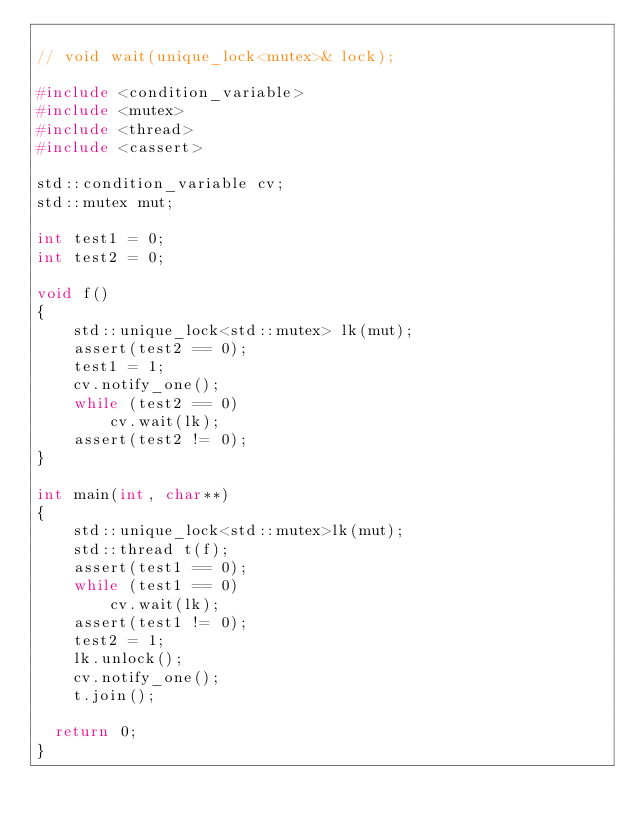Convert code to text. <code><loc_0><loc_0><loc_500><loc_500><_C++_>
// void wait(unique_lock<mutex>& lock);

#include <condition_variable>
#include <mutex>
#include <thread>
#include <cassert>

std::condition_variable cv;
std::mutex mut;

int test1 = 0;
int test2 = 0;

void f()
{
    std::unique_lock<std::mutex> lk(mut);
    assert(test2 == 0);
    test1 = 1;
    cv.notify_one();
    while (test2 == 0)
        cv.wait(lk);
    assert(test2 != 0);
}

int main(int, char**)
{
    std::unique_lock<std::mutex>lk(mut);
    std::thread t(f);
    assert(test1 == 0);
    while (test1 == 0)
        cv.wait(lk);
    assert(test1 != 0);
    test2 = 1;
    lk.unlock();
    cv.notify_one();
    t.join();

  return 0;
}
</code> 